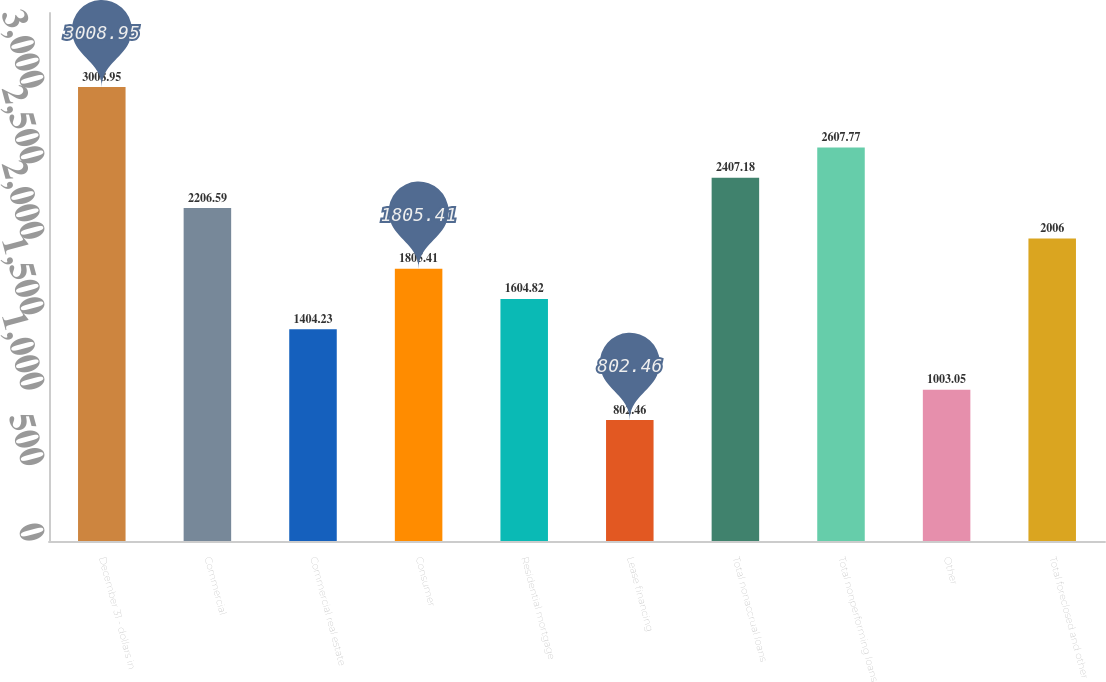<chart> <loc_0><loc_0><loc_500><loc_500><bar_chart><fcel>December 31 - dollars in<fcel>Commercial<fcel>Commercial real estate<fcel>Consumer<fcel>Residential mortgage<fcel>Lease financing<fcel>Total nonaccrual loans<fcel>Total nonperforming loans<fcel>Other<fcel>Total foreclosed and other<nl><fcel>3008.95<fcel>2206.59<fcel>1404.23<fcel>1805.41<fcel>1604.82<fcel>802.46<fcel>2407.18<fcel>2607.77<fcel>1003.05<fcel>2006<nl></chart> 